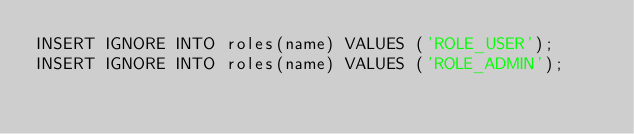<code> <loc_0><loc_0><loc_500><loc_500><_SQL_>INSERT IGNORE INTO roles(name) VALUES ('ROLE_USER');
INSERT IGNORE INTO roles(name) VALUES ('ROLE_ADMIN');</code> 